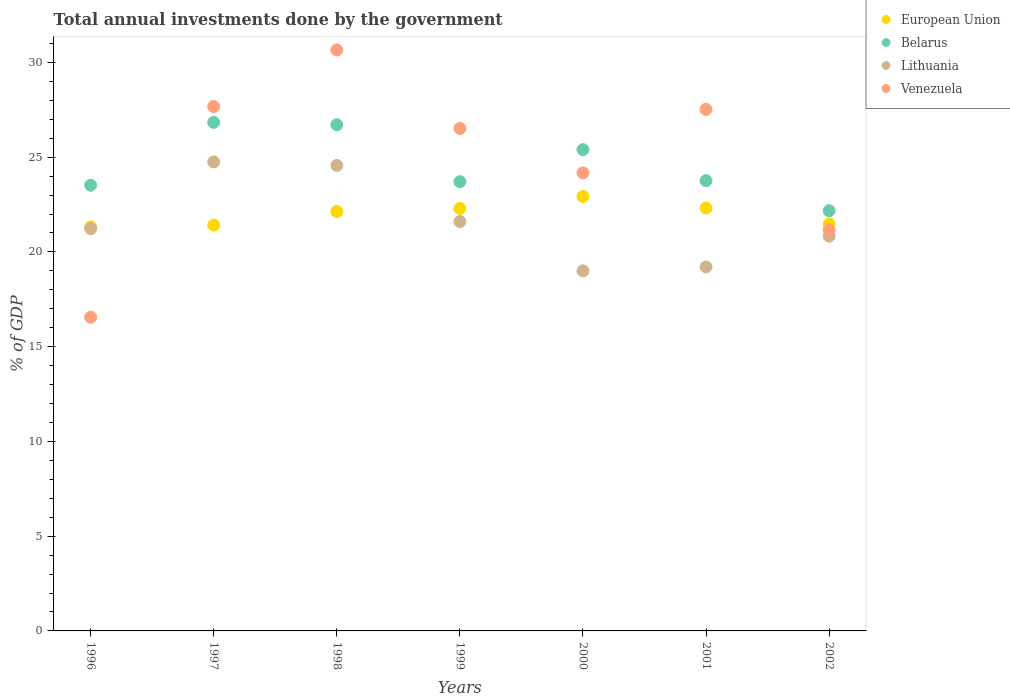How many different coloured dotlines are there?
Provide a succinct answer. 4. Is the number of dotlines equal to the number of legend labels?
Ensure brevity in your answer.  Yes. What is the total annual investments done by the government in European Union in 1999?
Your response must be concise. 22.3. Across all years, what is the maximum total annual investments done by the government in Lithuania?
Your answer should be compact. 24.75. Across all years, what is the minimum total annual investments done by the government in Venezuela?
Provide a succinct answer. 16.55. In which year was the total annual investments done by the government in European Union maximum?
Offer a very short reply. 2000. In which year was the total annual investments done by the government in Belarus minimum?
Keep it short and to the point. 2002. What is the total total annual investments done by the government in Venezuela in the graph?
Make the answer very short. 174.26. What is the difference between the total annual investments done by the government in Venezuela in 1998 and that in 2001?
Ensure brevity in your answer.  3.14. What is the difference between the total annual investments done by the government in Venezuela in 1998 and the total annual investments done by the government in European Union in 1997?
Ensure brevity in your answer.  9.25. What is the average total annual investments done by the government in European Union per year?
Keep it short and to the point. 21.98. In the year 1997, what is the difference between the total annual investments done by the government in Belarus and total annual investments done by the government in Venezuela?
Offer a very short reply. -0.84. In how many years, is the total annual investments done by the government in Venezuela greater than 9 %?
Keep it short and to the point. 7. What is the ratio of the total annual investments done by the government in European Union in 1997 to that in 1998?
Provide a succinct answer. 0.97. Is the difference between the total annual investments done by the government in Belarus in 1996 and 1997 greater than the difference between the total annual investments done by the government in Venezuela in 1996 and 1997?
Make the answer very short. Yes. What is the difference between the highest and the second highest total annual investments done by the government in European Union?
Offer a terse response. 0.61. What is the difference between the highest and the lowest total annual investments done by the government in Lithuania?
Provide a short and direct response. 5.75. Is the sum of the total annual investments done by the government in Venezuela in 2001 and 2002 greater than the maximum total annual investments done by the government in Lithuania across all years?
Make the answer very short. Yes. Is it the case that in every year, the sum of the total annual investments done by the government in Venezuela and total annual investments done by the government in Belarus  is greater than the sum of total annual investments done by the government in European Union and total annual investments done by the government in Lithuania?
Give a very brief answer. No. Is the total annual investments done by the government in Belarus strictly greater than the total annual investments done by the government in European Union over the years?
Provide a short and direct response. Yes. How many dotlines are there?
Provide a succinct answer. 4. How many years are there in the graph?
Keep it short and to the point. 7. What is the difference between two consecutive major ticks on the Y-axis?
Offer a terse response. 5. Are the values on the major ticks of Y-axis written in scientific E-notation?
Make the answer very short. No. How many legend labels are there?
Offer a terse response. 4. What is the title of the graph?
Give a very brief answer. Total annual investments done by the government. Does "Monaco" appear as one of the legend labels in the graph?
Offer a terse response. No. What is the label or title of the X-axis?
Your answer should be very brief. Years. What is the label or title of the Y-axis?
Ensure brevity in your answer.  % of GDP. What is the % of GDP in European Union in 1996?
Your response must be concise. 21.32. What is the % of GDP in Belarus in 1996?
Offer a terse response. 23.52. What is the % of GDP of Lithuania in 1996?
Ensure brevity in your answer.  21.23. What is the % of GDP in Venezuela in 1996?
Keep it short and to the point. 16.55. What is the % of GDP in European Union in 1997?
Provide a short and direct response. 21.41. What is the % of GDP in Belarus in 1997?
Give a very brief answer. 26.84. What is the % of GDP in Lithuania in 1997?
Offer a terse response. 24.75. What is the % of GDP in Venezuela in 1997?
Keep it short and to the point. 27.67. What is the % of GDP of European Union in 1998?
Offer a terse response. 22.13. What is the % of GDP of Belarus in 1998?
Your response must be concise. 26.71. What is the % of GDP in Lithuania in 1998?
Provide a succinct answer. 24.56. What is the % of GDP in Venezuela in 1998?
Provide a succinct answer. 30.66. What is the % of GDP of European Union in 1999?
Give a very brief answer. 22.3. What is the % of GDP in Belarus in 1999?
Make the answer very short. 23.71. What is the % of GDP in Lithuania in 1999?
Provide a succinct answer. 21.6. What is the % of GDP of Venezuela in 1999?
Offer a terse response. 26.52. What is the % of GDP of European Union in 2000?
Keep it short and to the point. 22.93. What is the % of GDP of Belarus in 2000?
Your answer should be very brief. 25.4. What is the % of GDP of Lithuania in 2000?
Keep it short and to the point. 19. What is the % of GDP of Venezuela in 2000?
Provide a succinct answer. 24.17. What is the % of GDP in European Union in 2001?
Keep it short and to the point. 22.31. What is the % of GDP in Belarus in 2001?
Offer a terse response. 23.76. What is the % of GDP in Lithuania in 2001?
Your answer should be compact. 19.21. What is the % of GDP of Venezuela in 2001?
Make the answer very short. 27.52. What is the % of GDP of European Union in 2002?
Provide a succinct answer. 21.48. What is the % of GDP in Belarus in 2002?
Your response must be concise. 22.18. What is the % of GDP of Lithuania in 2002?
Provide a succinct answer. 20.83. What is the % of GDP of Venezuela in 2002?
Ensure brevity in your answer.  21.16. Across all years, what is the maximum % of GDP in European Union?
Ensure brevity in your answer.  22.93. Across all years, what is the maximum % of GDP of Belarus?
Your answer should be very brief. 26.84. Across all years, what is the maximum % of GDP of Lithuania?
Provide a short and direct response. 24.75. Across all years, what is the maximum % of GDP in Venezuela?
Make the answer very short. 30.66. Across all years, what is the minimum % of GDP of European Union?
Your answer should be very brief. 21.32. Across all years, what is the minimum % of GDP of Belarus?
Give a very brief answer. 22.18. Across all years, what is the minimum % of GDP of Lithuania?
Provide a short and direct response. 19. Across all years, what is the minimum % of GDP in Venezuela?
Give a very brief answer. 16.55. What is the total % of GDP in European Union in the graph?
Make the answer very short. 153.88. What is the total % of GDP in Belarus in the graph?
Provide a short and direct response. 172.11. What is the total % of GDP of Lithuania in the graph?
Provide a short and direct response. 151.19. What is the total % of GDP of Venezuela in the graph?
Your answer should be very brief. 174.26. What is the difference between the % of GDP in European Union in 1996 and that in 1997?
Provide a short and direct response. -0.09. What is the difference between the % of GDP of Belarus in 1996 and that in 1997?
Ensure brevity in your answer.  -3.32. What is the difference between the % of GDP of Lithuania in 1996 and that in 1997?
Your response must be concise. -3.52. What is the difference between the % of GDP in Venezuela in 1996 and that in 1997?
Keep it short and to the point. -11.12. What is the difference between the % of GDP in European Union in 1996 and that in 1998?
Provide a short and direct response. -0.81. What is the difference between the % of GDP in Belarus in 1996 and that in 1998?
Ensure brevity in your answer.  -3.19. What is the difference between the % of GDP of Lithuania in 1996 and that in 1998?
Ensure brevity in your answer.  -3.33. What is the difference between the % of GDP in Venezuela in 1996 and that in 1998?
Your answer should be compact. -14.11. What is the difference between the % of GDP of European Union in 1996 and that in 1999?
Ensure brevity in your answer.  -0.97. What is the difference between the % of GDP in Belarus in 1996 and that in 1999?
Ensure brevity in your answer.  -0.19. What is the difference between the % of GDP of Lithuania in 1996 and that in 1999?
Offer a terse response. -0.38. What is the difference between the % of GDP of Venezuela in 1996 and that in 1999?
Keep it short and to the point. -9.96. What is the difference between the % of GDP of European Union in 1996 and that in 2000?
Provide a succinct answer. -1.6. What is the difference between the % of GDP in Belarus in 1996 and that in 2000?
Offer a very short reply. -1.88. What is the difference between the % of GDP of Lithuania in 1996 and that in 2000?
Provide a short and direct response. 2.23. What is the difference between the % of GDP of Venezuela in 1996 and that in 2000?
Ensure brevity in your answer.  -7.62. What is the difference between the % of GDP in European Union in 1996 and that in 2001?
Your answer should be very brief. -0.99. What is the difference between the % of GDP in Belarus in 1996 and that in 2001?
Your response must be concise. -0.24. What is the difference between the % of GDP in Lithuania in 1996 and that in 2001?
Ensure brevity in your answer.  2.02. What is the difference between the % of GDP of Venezuela in 1996 and that in 2001?
Ensure brevity in your answer.  -10.97. What is the difference between the % of GDP in European Union in 1996 and that in 2002?
Your response must be concise. -0.16. What is the difference between the % of GDP of Belarus in 1996 and that in 2002?
Give a very brief answer. 1.34. What is the difference between the % of GDP of Lithuania in 1996 and that in 2002?
Offer a very short reply. 0.4. What is the difference between the % of GDP of Venezuela in 1996 and that in 2002?
Make the answer very short. -4.6. What is the difference between the % of GDP of European Union in 1997 and that in 1998?
Ensure brevity in your answer.  -0.72. What is the difference between the % of GDP in Belarus in 1997 and that in 1998?
Make the answer very short. 0.12. What is the difference between the % of GDP in Lithuania in 1997 and that in 1998?
Give a very brief answer. 0.19. What is the difference between the % of GDP of Venezuela in 1997 and that in 1998?
Your answer should be compact. -2.99. What is the difference between the % of GDP in European Union in 1997 and that in 1999?
Your answer should be very brief. -0.88. What is the difference between the % of GDP in Belarus in 1997 and that in 1999?
Your answer should be very brief. 3.13. What is the difference between the % of GDP in Lithuania in 1997 and that in 1999?
Your response must be concise. 3.15. What is the difference between the % of GDP of Venezuela in 1997 and that in 1999?
Your answer should be compact. 1.16. What is the difference between the % of GDP in European Union in 1997 and that in 2000?
Your answer should be compact. -1.51. What is the difference between the % of GDP of Belarus in 1997 and that in 2000?
Offer a terse response. 1.44. What is the difference between the % of GDP in Lithuania in 1997 and that in 2000?
Offer a very short reply. 5.75. What is the difference between the % of GDP in Venezuela in 1997 and that in 2000?
Offer a very short reply. 3.5. What is the difference between the % of GDP in European Union in 1997 and that in 2001?
Your answer should be compact. -0.9. What is the difference between the % of GDP of Belarus in 1997 and that in 2001?
Offer a very short reply. 3.08. What is the difference between the % of GDP of Lithuania in 1997 and that in 2001?
Your answer should be compact. 5.54. What is the difference between the % of GDP of Venezuela in 1997 and that in 2001?
Your answer should be compact. 0.15. What is the difference between the % of GDP in European Union in 1997 and that in 2002?
Provide a short and direct response. -0.06. What is the difference between the % of GDP of Belarus in 1997 and that in 2002?
Your response must be concise. 4.66. What is the difference between the % of GDP in Lithuania in 1997 and that in 2002?
Offer a very short reply. 3.92. What is the difference between the % of GDP of Venezuela in 1997 and that in 2002?
Make the answer very short. 6.51. What is the difference between the % of GDP in European Union in 1998 and that in 1999?
Keep it short and to the point. -0.16. What is the difference between the % of GDP in Belarus in 1998 and that in 1999?
Provide a short and direct response. 3.01. What is the difference between the % of GDP in Lithuania in 1998 and that in 1999?
Offer a terse response. 2.96. What is the difference between the % of GDP in Venezuela in 1998 and that in 1999?
Offer a very short reply. 4.14. What is the difference between the % of GDP in European Union in 1998 and that in 2000?
Your answer should be compact. -0.79. What is the difference between the % of GDP of Belarus in 1998 and that in 2000?
Your answer should be very brief. 1.31. What is the difference between the % of GDP of Lithuania in 1998 and that in 2000?
Your response must be concise. 5.56. What is the difference between the % of GDP of Venezuela in 1998 and that in 2000?
Make the answer very short. 6.49. What is the difference between the % of GDP in European Union in 1998 and that in 2001?
Give a very brief answer. -0.18. What is the difference between the % of GDP in Belarus in 1998 and that in 2001?
Offer a terse response. 2.95. What is the difference between the % of GDP of Lithuania in 1998 and that in 2001?
Your response must be concise. 5.36. What is the difference between the % of GDP in Venezuela in 1998 and that in 2001?
Offer a terse response. 3.14. What is the difference between the % of GDP in European Union in 1998 and that in 2002?
Ensure brevity in your answer.  0.66. What is the difference between the % of GDP of Belarus in 1998 and that in 2002?
Offer a terse response. 4.54. What is the difference between the % of GDP in Lithuania in 1998 and that in 2002?
Offer a very short reply. 3.73. What is the difference between the % of GDP of Venezuela in 1998 and that in 2002?
Give a very brief answer. 9.5. What is the difference between the % of GDP in European Union in 1999 and that in 2000?
Keep it short and to the point. -0.63. What is the difference between the % of GDP in Belarus in 1999 and that in 2000?
Keep it short and to the point. -1.69. What is the difference between the % of GDP in Lithuania in 1999 and that in 2000?
Your answer should be compact. 2.6. What is the difference between the % of GDP of Venezuela in 1999 and that in 2000?
Ensure brevity in your answer.  2.35. What is the difference between the % of GDP in European Union in 1999 and that in 2001?
Your response must be concise. -0.02. What is the difference between the % of GDP of Belarus in 1999 and that in 2001?
Offer a very short reply. -0.05. What is the difference between the % of GDP in Lithuania in 1999 and that in 2001?
Give a very brief answer. 2.4. What is the difference between the % of GDP of Venezuela in 1999 and that in 2001?
Offer a very short reply. -1.01. What is the difference between the % of GDP of European Union in 1999 and that in 2002?
Keep it short and to the point. 0.82. What is the difference between the % of GDP of Belarus in 1999 and that in 2002?
Ensure brevity in your answer.  1.53. What is the difference between the % of GDP of Lithuania in 1999 and that in 2002?
Your answer should be compact. 0.77. What is the difference between the % of GDP in Venezuela in 1999 and that in 2002?
Your answer should be very brief. 5.36. What is the difference between the % of GDP in European Union in 2000 and that in 2001?
Ensure brevity in your answer.  0.61. What is the difference between the % of GDP of Belarus in 2000 and that in 2001?
Provide a short and direct response. 1.64. What is the difference between the % of GDP of Lithuania in 2000 and that in 2001?
Your answer should be very brief. -0.21. What is the difference between the % of GDP in Venezuela in 2000 and that in 2001?
Give a very brief answer. -3.35. What is the difference between the % of GDP in European Union in 2000 and that in 2002?
Make the answer very short. 1.45. What is the difference between the % of GDP in Belarus in 2000 and that in 2002?
Give a very brief answer. 3.22. What is the difference between the % of GDP in Lithuania in 2000 and that in 2002?
Your response must be concise. -1.83. What is the difference between the % of GDP of Venezuela in 2000 and that in 2002?
Your answer should be very brief. 3.01. What is the difference between the % of GDP in European Union in 2001 and that in 2002?
Offer a terse response. 0.84. What is the difference between the % of GDP of Belarus in 2001 and that in 2002?
Your answer should be compact. 1.58. What is the difference between the % of GDP in Lithuania in 2001 and that in 2002?
Your response must be concise. -1.63. What is the difference between the % of GDP of Venezuela in 2001 and that in 2002?
Offer a very short reply. 6.37. What is the difference between the % of GDP of European Union in 1996 and the % of GDP of Belarus in 1997?
Offer a very short reply. -5.52. What is the difference between the % of GDP in European Union in 1996 and the % of GDP in Lithuania in 1997?
Make the answer very short. -3.43. What is the difference between the % of GDP of European Union in 1996 and the % of GDP of Venezuela in 1997?
Ensure brevity in your answer.  -6.35. What is the difference between the % of GDP in Belarus in 1996 and the % of GDP in Lithuania in 1997?
Offer a terse response. -1.23. What is the difference between the % of GDP of Belarus in 1996 and the % of GDP of Venezuela in 1997?
Offer a very short reply. -4.15. What is the difference between the % of GDP in Lithuania in 1996 and the % of GDP in Venezuela in 1997?
Keep it short and to the point. -6.44. What is the difference between the % of GDP of European Union in 1996 and the % of GDP of Belarus in 1998?
Make the answer very short. -5.39. What is the difference between the % of GDP in European Union in 1996 and the % of GDP in Lithuania in 1998?
Provide a succinct answer. -3.24. What is the difference between the % of GDP in European Union in 1996 and the % of GDP in Venezuela in 1998?
Your answer should be very brief. -9.34. What is the difference between the % of GDP in Belarus in 1996 and the % of GDP in Lithuania in 1998?
Give a very brief answer. -1.05. What is the difference between the % of GDP of Belarus in 1996 and the % of GDP of Venezuela in 1998?
Provide a short and direct response. -7.14. What is the difference between the % of GDP in Lithuania in 1996 and the % of GDP in Venezuela in 1998?
Your answer should be very brief. -9.43. What is the difference between the % of GDP of European Union in 1996 and the % of GDP of Belarus in 1999?
Your response must be concise. -2.39. What is the difference between the % of GDP in European Union in 1996 and the % of GDP in Lithuania in 1999?
Your response must be concise. -0.28. What is the difference between the % of GDP in European Union in 1996 and the % of GDP in Venezuela in 1999?
Keep it short and to the point. -5.2. What is the difference between the % of GDP in Belarus in 1996 and the % of GDP in Lithuania in 1999?
Offer a terse response. 1.91. What is the difference between the % of GDP in Belarus in 1996 and the % of GDP in Venezuela in 1999?
Provide a succinct answer. -3. What is the difference between the % of GDP in Lithuania in 1996 and the % of GDP in Venezuela in 1999?
Make the answer very short. -5.29. What is the difference between the % of GDP in European Union in 1996 and the % of GDP in Belarus in 2000?
Give a very brief answer. -4.08. What is the difference between the % of GDP of European Union in 1996 and the % of GDP of Lithuania in 2000?
Ensure brevity in your answer.  2.32. What is the difference between the % of GDP in European Union in 1996 and the % of GDP in Venezuela in 2000?
Make the answer very short. -2.85. What is the difference between the % of GDP of Belarus in 1996 and the % of GDP of Lithuania in 2000?
Your answer should be very brief. 4.52. What is the difference between the % of GDP of Belarus in 1996 and the % of GDP of Venezuela in 2000?
Make the answer very short. -0.65. What is the difference between the % of GDP of Lithuania in 1996 and the % of GDP of Venezuela in 2000?
Ensure brevity in your answer.  -2.94. What is the difference between the % of GDP in European Union in 1996 and the % of GDP in Belarus in 2001?
Offer a very short reply. -2.44. What is the difference between the % of GDP of European Union in 1996 and the % of GDP of Lithuania in 2001?
Provide a short and direct response. 2.11. What is the difference between the % of GDP in European Union in 1996 and the % of GDP in Venezuela in 2001?
Make the answer very short. -6.2. What is the difference between the % of GDP in Belarus in 1996 and the % of GDP in Lithuania in 2001?
Offer a terse response. 4.31. What is the difference between the % of GDP in Belarus in 1996 and the % of GDP in Venezuela in 2001?
Keep it short and to the point. -4.01. What is the difference between the % of GDP in Lithuania in 1996 and the % of GDP in Venezuela in 2001?
Your response must be concise. -6.29. What is the difference between the % of GDP in European Union in 1996 and the % of GDP in Belarus in 2002?
Offer a terse response. -0.86. What is the difference between the % of GDP of European Union in 1996 and the % of GDP of Lithuania in 2002?
Your answer should be compact. 0.49. What is the difference between the % of GDP in European Union in 1996 and the % of GDP in Venezuela in 2002?
Offer a terse response. 0.16. What is the difference between the % of GDP of Belarus in 1996 and the % of GDP of Lithuania in 2002?
Provide a succinct answer. 2.69. What is the difference between the % of GDP of Belarus in 1996 and the % of GDP of Venezuela in 2002?
Offer a very short reply. 2.36. What is the difference between the % of GDP in Lithuania in 1996 and the % of GDP in Venezuela in 2002?
Keep it short and to the point. 0.07. What is the difference between the % of GDP of European Union in 1997 and the % of GDP of Belarus in 1998?
Ensure brevity in your answer.  -5.3. What is the difference between the % of GDP in European Union in 1997 and the % of GDP in Lithuania in 1998?
Offer a terse response. -3.15. What is the difference between the % of GDP in European Union in 1997 and the % of GDP in Venezuela in 1998?
Make the answer very short. -9.25. What is the difference between the % of GDP in Belarus in 1997 and the % of GDP in Lithuania in 1998?
Your response must be concise. 2.27. What is the difference between the % of GDP of Belarus in 1997 and the % of GDP of Venezuela in 1998?
Offer a very short reply. -3.82. What is the difference between the % of GDP of Lithuania in 1997 and the % of GDP of Venezuela in 1998?
Your response must be concise. -5.91. What is the difference between the % of GDP in European Union in 1997 and the % of GDP in Belarus in 1999?
Offer a terse response. -2.29. What is the difference between the % of GDP of European Union in 1997 and the % of GDP of Lithuania in 1999?
Give a very brief answer. -0.19. What is the difference between the % of GDP of European Union in 1997 and the % of GDP of Venezuela in 1999?
Make the answer very short. -5.1. What is the difference between the % of GDP of Belarus in 1997 and the % of GDP of Lithuania in 1999?
Provide a succinct answer. 5.23. What is the difference between the % of GDP in Belarus in 1997 and the % of GDP in Venezuela in 1999?
Your answer should be very brief. 0.32. What is the difference between the % of GDP in Lithuania in 1997 and the % of GDP in Venezuela in 1999?
Offer a very short reply. -1.76. What is the difference between the % of GDP of European Union in 1997 and the % of GDP of Belarus in 2000?
Offer a very short reply. -3.98. What is the difference between the % of GDP of European Union in 1997 and the % of GDP of Lithuania in 2000?
Your answer should be very brief. 2.41. What is the difference between the % of GDP in European Union in 1997 and the % of GDP in Venezuela in 2000?
Offer a terse response. -2.76. What is the difference between the % of GDP in Belarus in 1997 and the % of GDP in Lithuania in 2000?
Your response must be concise. 7.83. What is the difference between the % of GDP of Belarus in 1997 and the % of GDP of Venezuela in 2000?
Provide a short and direct response. 2.67. What is the difference between the % of GDP in Lithuania in 1997 and the % of GDP in Venezuela in 2000?
Your answer should be compact. 0.58. What is the difference between the % of GDP in European Union in 1997 and the % of GDP in Belarus in 2001?
Your response must be concise. -2.35. What is the difference between the % of GDP of European Union in 1997 and the % of GDP of Lithuania in 2001?
Keep it short and to the point. 2.21. What is the difference between the % of GDP of European Union in 1997 and the % of GDP of Venezuela in 2001?
Provide a succinct answer. -6.11. What is the difference between the % of GDP in Belarus in 1997 and the % of GDP in Lithuania in 2001?
Offer a terse response. 7.63. What is the difference between the % of GDP of Belarus in 1997 and the % of GDP of Venezuela in 2001?
Offer a terse response. -0.69. What is the difference between the % of GDP of Lithuania in 1997 and the % of GDP of Venezuela in 2001?
Your answer should be very brief. -2.77. What is the difference between the % of GDP in European Union in 1997 and the % of GDP in Belarus in 2002?
Provide a succinct answer. -0.76. What is the difference between the % of GDP in European Union in 1997 and the % of GDP in Lithuania in 2002?
Your answer should be very brief. 0.58. What is the difference between the % of GDP in European Union in 1997 and the % of GDP in Venezuela in 2002?
Offer a terse response. 0.26. What is the difference between the % of GDP in Belarus in 1997 and the % of GDP in Lithuania in 2002?
Keep it short and to the point. 6. What is the difference between the % of GDP in Belarus in 1997 and the % of GDP in Venezuela in 2002?
Your answer should be compact. 5.68. What is the difference between the % of GDP in Lithuania in 1997 and the % of GDP in Venezuela in 2002?
Make the answer very short. 3.59. What is the difference between the % of GDP in European Union in 1998 and the % of GDP in Belarus in 1999?
Make the answer very short. -1.57. What is the difference between the % of GDP in European Union in 1998 and the % of GDP in Lithuania in 1999?
Your response must be concise. 0.53. What is the difference between the % of GDP in European Union in 1998 and the % of GDP in Venezuela in 1999?
Your answer should be compact. -4.38. What is the difference between the % of GDP of Belarus in 1998 and the % of GDP of Lithuania in 1999?
Make the answer very short. 5.11. What is the difference between the % of GDP in Belarus in 1998 and the % of GDP in Venezuela in 1999?
Your response must be concise. 0.2. What is the difference between the % of GDP of Lithuania in 1998 and the % of GDP of Venezuela in 1999?
Give a very brief answer. -1.95. What is the difference between the % of GDP in European Union in 1998 and the % of GDP in Belarus in 2000?
Your answer should be compact. -3.26. What is the difference between the % of GDP of European Union in 1998 and the % of GDP of Lithuania in 2000?
Provide a short and direct response. 3.13. What is the difference between the % of GDP in European Union in 1998 and the % of GDP in Venezuela in 2000?
Ensure brevity in your answer.  -2.04. What is the difference between the % of GDP of Belarus in 1998 and the % of GDP of Lithuania in 2000?
Your response must be concise. 7.71. What is the difference between the % of GDP in Belarus in 1998 and the % of GDP in Venezuela in 2000?
Offer a very short reply. 2.54. What is the difference between the % of GDP in Lithuania in 1998 and the % of GDP in Venezuela in 2000?
Keep it short and to the point. 0.39. What is the difference between the % of GDP in European Union in 1998 and the % of GDP in Belarus in 2001?
Your answer should be compact. -1.63. What is the difference between the % of GDP of European Union in 1998 and the % of GDP of Lithuania in 2001?
Ensure brevity in your answer.  2.93. What is the difference between the % of GDP in European Union in 1998 and the % of GDP in Venezuela in 2001?
Give a very brief answer. -5.39. What is the difference between the % of GDP of Belarus in 1998 and the % of GDP of Lithuania in 2001?
Give a very brief answer. 7.5. What is the difference between the % of GDP in Belarus in 1998 and the % of GDP in Venezuela in 2001?
Keep it short and to the point. -0.81. What is the difference between the % of GDP in Lithuania in 1998 and the % of GDP in Venezuela in 2001?
Ensure brevity in your answer.  -2.96. What is the difference between the % of GDP in European Union in 1998 and the % of GDP in Belarus in 2002?
Make the answer very short. -0.04. What is the difference between the % of GDP in European Union in 1998 and the % of GDP in Lithuania in 2002?
Offer a very short reply. 1.3. What is the difference between the % of GDP of European Union in 1998 and the % of GDP of Venezuela in 2002?
Your response must be concise. 0.98. What is the difference between the % of GDP of Belarus in 1998 and the % of GDP of Lithuania in 2002?
Your response must be concise. 5.88. What is the difference between the % of GDP of Belarus in 1998 and the % of GDP of Venezuela in 2002?
Keep it short and to the point. 5.55. What is the difference between the % of GDP in Lithuania in 1998 and the % of GDP in Venezuela in 2002?
Offer a terse response. 3.41. What is the difference between the % of GDP of European Union in 1999 and the % of GDP of Belarus in 2000?
Keep it short and to the point. -3.1. What is the difference between the % of GDP of European Union in 1999 and the % of GDP of Lithuania in 2000?
Your response must be concise. 3.29. What is the difference between the % of GDP in European Union in 1999 and the % of GDP in Venezuela in 2000?
Provide a short and direct response. -1.88. What is the difference between the % of GDP of Belarus in 1999 and the % of GDP of Lithuania in 2000?
Give a very brief answer. 4.7. What is the difference between the % of GDP of Belarus in 1999 and the % of GDP of Venezuela in 2000?
Provide a succinct answer. -0.46. What is the difference between the % of GDP in Lithuania in 1999 and the % of GDP in Venezuela in 2000?
Offer a very short reply. -2.57. What is the difference between the % of GDP of European Union in 1999 and the % of GDP of Belarus in 2001?
Make the answer very short. -1.47. What is the difference between the % of GDP of European Union in 1999 and the % of GDP of Lithuania in 2001?
Your answer should be very brief. 3.09. What is the difference between the % of GDP of European Union in 1999 and the % of GDP of Venezuela in 2001?
Your answer should be compact. -5.23. What is the difference between the % of GDP in Belarus in 1999 and the % of GDP in Lithuania in 2001?
Your answer should be compact. 4.5. What is the difference between the % of GDP of Belarus in 1999 and the % of GDP of Venezuela in 2001?
Give a very brief answer. -3.82. What is the difference between the % of GDP of Lithuania in 1999 and the % of GDP of Venezuela in 2001?
Ensure brevity in your answer.  -5.92. What is the difference between the % of GDP of European Union in 1999 and the % of GDP of Belarus in 2002?
Give a very brief answer. 0.12. What is the difference between the % of GDP of European Union in 1999 and the % of GDP of Lithuania in 2002?
Provide a succinct answer. 1.46. What is the difference between the % of GDP of European Union in 1999 and the % of GDP of Venezuela in 2002?
Your answer should be very brief. 1.14. What is the difference between the % of GDP in Belarus in 1999 and the % of GDP in Lithuania in 2002?
Make the answer very short. 2.87. What is the difference between the % of GDP in Belarus in 1999 and the % of GDP in Venezuela in 2002?
Make the answer very short. 2.55. What is the difference between the % of GDP of Lithuania in 1999 and the % of GDP of Venezuela in 2002?
Keep it short and to the point. 0.45. What is the difference between the % of GDP of European Union in 2000 and the % of GDP of Belarus in 2001?
Ensure brevity in your answer.  -0.83. What is the difference between the % of GDP in European Union in 2000 and the % of GDP in Lithuania in 2001?
Provide a short and direct response. 3.72. What is the difference between the % of GDP in European Union in 2000 and the % of GDP in Venezuela in 2001?
Keep it short and to the point. -4.6. What is the difference between the % of GDP in Belarus in 2000 and the % of GDP in Lithuania in 2001?
Provide a succinct answer. 6.19. What is the difference between the % of GDP in Belarus in 2000 and the % of GDP in Venezuela in 2001?
Provide a succinct answer. -2.13. What is the difference between the % of GDP in Lithuania in 2000 and the % of GDP in Venezuela in 2001?
Provide a short and direct response. -8.52. What is the difference between the % of GDP in European Union in 2000 and the % of GDP in Belarus in 2002?
Ensure brevity in your answer.  0.75. What is the difference between the % of GDP in European Union in 2000 and the % of GDP in Lithuania in 2002?
Your response must be concise. 2.09. What is the difference between the % of GDP in European Union in 2000 and the % of GDP in Venezuela in 2002?
Keep it short and to the point. 1.77. What is the difference between the % of GDP in Belarus in 2000 and the % of GDP in Lithuania in 2002?
Provide a succinct answer. 4.57. What is the difference between the % of GDP in Belarus in 2000 and the % of GDP in Venezuela in 2002?
Offer a terse response. 4.24. What is the difference between the % of GDP in Lithuania in 2000 and the % of GDP in Venezuela in 2002?
Provide a succinct answer. -2.16. What is the difference between the % of GDP of European Union in 2001 and the % of GDP of Belarus in 2002?
Offer a terse response. 0.14. What is the difference between the % of GDP of European Union in 2001 and the % of GDP of Lithuania in 2002?
Your answer should be very brief. 1.48. What is the difference between the % of GDP in European Union in 2001 and the % of GDP in Venezuela in 2002?
Keep it short and to the point. 1.16. What is the difference between the % of GDP in Belarus in 2001 and the % of GDP in Lithuania in 2002?
Your answer should be compact. 2.93. What is the difference between the % of GDP of Belarus in 2001 and the % of GDP of Venezuela in 2002?
Offer a very short reply. 2.6. What is the difference between the % of GDP of Lithuania in 2001 and the % of GDP of Venezuela in 2002?
Provide a short and direct response. -1.95. What is the average % of GDP of European Union per year?
Your answer should be compact. 21.98. What is the average % of GDP of Belarus per year?
Offer a very short reply. 24.59. What is the average % of GDP in Lithuania per year?
Offer a terse response. 21.6. What is the average % of GDP in Venezuela per year?
Your answer should be very brief. 24.89. In the year 1996, what is the difference between the % of GDP of European Union and % of GDP of Belarus?
Keep it short and to the point. -2.2. In the year 1996, what is the difference between the % of GDP in European Union and % of GDP in Lithuania?
Make the answer very short. 0.09. In the year 1996, what is the difference between the % of GDP of European Union and % of GDP of Venezuela?
Give a very brief answer. 4.77. In the year 1996, what is the difference between the % of GDP in Belarus and % of GDP in Lithuania?
Keep it short and to the point. 2.29. In the year 1996, what is the difference between the % of GDP in Belarus and % of GDP in Venezuela?
Offer a terse response. 6.96. In the year 1996, what is the difference between the % of GDP in Lithuania and % of GDP in Venezuela?
Make the answer very short. 4.67. In the year 1997, what is the difference between the % of GDP in European Union and % of GDP in Belarus?
Your response must be concise. -5.42. In the year 1997, what is the difference between the % of GDP of European Union and % of GDP of Lithuania?
Keep it short and to the point. -3.34. In the year 1997, what is the difference between the % of GDP in European Union and % of GDP in Venezuela?
Keep it short and to the point. -6.26. In the year 1997, what is the difference between the % of GDP in Belarus and % of GDP in Lithuania?
Ensure brevity in your answer.  2.08. In the year 1997, what is the difference between the % of GDP of Belarus and % of GDP of Venezuela?
Keep it short and to the point. -0.84. In the year 1997, what is the difference between the % of GDP in Lithuania and % of GDP in Venezuela?
Your answer should be compact. -2.92. In the year 1998, what is the difference between the % of GDP in European Union and % of GDP in Belarus?
Provide a succinct answer. -4.58. In the year 1998, what is the difference between the % of GDP in European Union and % of GDP in Lithuania?
Your answer should be compact. -2.43. In the year 1998, what is the difference between the % of GDP of European Union and % of GDP of Venezuela?
Ensure brevity in your answer.  -8.53. In the year 1998, what is the difference between the % of GDP in Belarus and % of GDP in Lithuania?
Your answer should be compact. 2.15. In the year 1998, what is the difference between the % of GDP of Belarus and % of GDP of Venezuela?
Provide a succinct answer. -3.95. In the year 1998, what is the difference between the % of GDP in Lithuania and % of GDP in Venezuela?
Offer a terse response. -6.1. In the year 1999, what is the difference between the % of GDP in European Union and % of GDP in Belarus?
Keep it short and to the point. -1.41. In the year 1999, what is the difference between the % of GDP in European Union and % of GDP in Lithuania?
Give a very brief answer. 0.69. In the year 1999, what is the difference between the % of GDP in European Union and % of GDP in Venezuela?
Keep it short and to the point. -4.22. In the year 1999, what is the difference between the % of GDP of Belarus and % of GDP of Lithuania?
Your answer should be compact. 2.1. In the year 1999, what is the difference between the % of GDP of Belarus and % of GDP of Venezuela?
Provide a short and direct response. -2.81. In the year 1999, what is the difference between the % of GDP of Lithuania and % of GDP of Venezuela?
Make the answer very short. -4.91. In the year 2000, what is the difference between the % of GDP in European Union and % of GDP in Belarus?
Ensure brevity in your answer.  -2.47. In the year 2000, what is the difference between the % of GDP of European Union and % of GDP of Lithuania?
Ensure brevity in your answer.  3.92. In the year 2000, what is the difference between the % of GDP in European Union and % of GDP in Venezuela?
Keep it short and to the point. -1.24. In the year 2000, what is the difference between the % of GDP of Belarus and % of GDP of Lithuania?
Make the answer very short. 6.4. In the year 2000, what is the difference between the % of GDP of Belarus and % of GDP of Venezuela?
Keep it short and to the point. 1.23. In the year 2000, what is the difference between the % of GDP in Lithuania and % of GDP in Venezuela?
Offer a terse response. -5.17. In the year 2001, what is the difference between the % of GDP in European Union and % of GDP in Belarus?
Your response must be concise. -1.45. In the year 2001, what is the difference between the % of GDP in European Union and % of GDP in Lithuania?
Make the answer very short. 3.11. In the year 2001, what is the difference between the % of GDP of European Union and % of GDP of Venezuela?
Keep it short and to the point. -5.21. In the year 2001, what is the difference between the % of GDP of Belarus and % of GDP of Lithuania?
Your answer should be compact. 4.55. In the year 2001, what is the difference between the % of GDP in Belarus and % of GDP in Venezuela?
Offer a very short reply. -3.76. In the year 2001, what is the difference between the % of GDP of Lithuania and % of GDP of Venezuela?
Your answer should be compact. -8.32. In the year 2002, what is the difference between the % of GDP in European Union and % of GDP in Belarus?
Make the answer very short. -0.7. In the year 2002, what is the difference between the % of GDP in European Union and % of GDP in Lithuania?
Make the answer very short. 0.64. In the year 2002, what is the difference between the % of GDP of European Union and % of GDP of Venezuela?
Ensure brevity in your answer.  0.32. In the year 2002, what is the difference between the % of GDP of Belarus and % of GDP of Lithuania?
Offer a terse response. 1.34. In the year 2002, what is the difference between the % of GDP of Belarus and % of GDP of Venezuela?
Ensure brevity in your answer.  1.02. In the year 2002, what is the difference between the % of GDP in Lithuania and % of GDP in Venezuela?
Keep it short and to the point. -0.33. What is the ratio of the % of GDP in European Union in 1996 to that in 1997?
Make the answer very short. 1. What is the ratio of the % of GDP in Belarus in 1996 to that in 1997?
Your answer should be very brief. 0.88. What is the ratio of the % of GDP of Lithuania in 1996 to that in 1997?
Offer a terse response. 0.86. What is the ratio of the % of GDP in Venezuela in 1996 to that in 1997?
Offer a terse response. 0.6. What is the ratio of the % of GDP in European Union in 1996 to that in 1998?
Make the answer very short. 0.96. What is the ratio of the % of GDP in Belarus in 1996 to that in 1998?
Your answer should be compact. 0.88. What is the ratio of the % of GDP in Lithuania in 1996 to that in 1998?
Your response must be concise. 0.86. What is the ratio of the % of GDP in Venezuela in 1996 to that in 1998?
Provide a succinct answer. 0.54. What is the ratio of the % of GDP of European Union in 1996 to that in 1999?
Provide a short and direct response. 0.96. What is the ratio of the % of GDP in Lithuania in 1996 to that in 1999?
Your answer should be compact. 0.98. What is the ratio of the % of GDP in Venezuela in 1996 to that in 1999?
Offer a terse response. 0.62. What is the ratio of the % of GDP of Belarus in 1996 to that in 2000?
Make the answer very short. 0.93. What is the ratio of the % of GDP of Lithuania in 1996 to that in 2000?
Your answer should be very brief. 1.12. What is the ratio of the % of GDP of Venezuela in 1996 to that in 2000?
Ensure brevity in your answer.  0.68. What is the ratio of the % of GDP of European Union in 1996 to that in 2001?
Keep it short and to the point. 0.96. What is the ratio of the % of GDP of Belarus in 1996 to that in 2001?
Offer a very short reply. 0.99. What is the ratio of the % of GDP of Lithuania in 1996 to that in 2001?
Keep it short and to the point. 1.11. What is the ratio of the % of GDP of Venezuela in 1996 to that in 2001?
Provide a succinct answer. 0.6. What is the ratio of the % of GDP of Belarus in 1996 to that in 2002?
Keep it short and to the point. 1.06. What is the ratio of the % of GDP in Lithuania in 1996 to that in 2002?
Your answer should be very brief. 1.02. What is the ratio of the % of GDP in Venezuela in 1996 to that in 2002?
Your answer should be very brief. 0.78. What is the ratio of the % of GDP of European Union in 1997 to that in 1998?
Your answer should be very brief. 0.97. What is the ratio of the % of GDP in Lithuania in 1997 to that in 1998?
Offer a terse response. 1.01. What is the ratio of the % of GDP of Venezuela in 1997 to that in 1998?
Ensure brevity in your answer.  0.9. What is the ratio of the % of GDP in European Union in 1997 to that in 1999?
Make the answer very short. 0.96. What is the ratio of the % of GDP of Belarus in 1997 to that in 1999?
Your response must be concise. 1.13. What is the ratio of the % of GDP of Lithuania in 1997 to that in 1999?
Make the answer very short. 1.15. What is the ratio of the % of GDP of Venezuela in 1997 to that in 1999?
Your response must be concise. 1.04. What is the ratio of the % of GDP in European Union in 1997 to that in 2000?
Make the answer very short. 0.93. What is the ratio of the % of GDP of Belarus in 1997 to that in 2000?
Keep it short and to the point. 1.06. What is the ratio of the % of GDP in Lithuania in 1997 to that in 2000?
Give a very brief answer. 1.3. What is the ratio of the % of GDP of Venezuela in 1997 to that in 2000?
Provide a succinct answer. 1.14. What is the ratio of the % of GDP of European Union in 1997 to that in 2001?
Offer a terse response. 0.96. What is the ratio of the % of GDP of Belarus in 1997 to that in 2001?
Your answer should be compact. 1.13. What is the ratio of the % of GDP in Lithuania in 1997 to that in 2001?
Provide a succinct answer. 1.29. What is the ratio of the % of GDP of Venezuela in 1997 to that in 2001?
Provide a succinct answer. 1.01. What is the ratio of the % of GDP of Belarus in 1997 to that in 2002?
Give a very brief answer. 1.21. What is the ratio of the % of GDP in Lithuania in 1997 to that in 2002?
Your response must be concise. 1.19. What is the ratio of the % of GDP of Venezuela in 1997 to that in 2002?
Give a very brief answer. 1.31. What is the ratio of the % of GDP of Belarus in 1998 to that in 1999?
Keep it short and to the point. 1.13. What is the ratio of the % of GDP of Lithuania in 1998 to that in 1999?
Offer a very short reply. 1.14. What is the ratio of the % of GDP of Venezuela in 1998 to that in 1999?
Provide a succinct answer. 1.16. What is the ratio of the % of GDP of European Union in 1998 to that in 2000?
Make the answer very short. 0.97. What is the ratio of the % of GDP of Belarus in 1998 to that in 2000?
Keep it short and to the point. 1.05. What is the ratio of the % of GDP in Lithuania in 1998 to that in 2000?
Provide a short and direct response. 1.29. What is the ratio of the % of GDP of Venezuela in 1998 to that in 2000?
Provide a short and direct response. 1.27. What is the ratio of the % of GDP of Belarus in 1998 to that in 2001?
Your answer should be very brief. 1.12. What is the ratio of the % of GDP in Lithuania in 1998 to that in 2001?
Offer a terse response. 1.28. What is the ratio of the % of GDP in Venezuela in 1998 to that in 2001?
Your answer should be very brief. 1.11. What is the ratio of the % of GDP of European Union in 1998 to that in 2002?
Give a very brief answer. 1.03. What is the ratio of the % of GDP in Belarus in 1998 to that in 2002?
Your answer should be compact. 1.2. What is the ratio of the % of GDP in Lithuania in 1998 to that in 2002?
Provide a succinct answer. 1.18. What is the ratio of the % of GDP of Venezuela in 1998 to that in 2002?
Your answer should be compact. 1.45. What is the ratio of the % of GDP of European Union in 1999 to that in 2000?
Provide a short and direct response. 0.97. What is the ratio of the % of GDP of Belarus in 1999 to that in 2000?
Your response must be concise. 0.93. What is the ratio of the % of GDP in Lithuania in 1999 to that in 2000?
Offer a terse response. 1.14. What is the ratio of the % of GDP of Venezuela in 1999 to that in 2000?
Provide a short and direct response. 1.1. What is the ratio of the % of GDP of Lithuania in 1999 to that in 2001?
Your response must be concise. 1.12. What is the ratio of the % of GDP of Venezuela in 1999 to that in 2001?
Provide a short and direct response. 0.96. What is the ratio of the % of GDP in European Union in 1999 to that in 2002?
Give a very brief answer. 1.04. What is the ratio of the % of GDP in Belarus in 1999 to that in 2002?
Offer a very short reply. 1.07. What is the ratio of the % of GDP of Venezuela in 1999 to that in 2002?
Provide a short and direct response. 1.25. What is the ratio of the % of GDP in European Union in 2000 to that in 2001?
Your response must be concise. 1.03. What is the ratio of the % of GDP in Belarus in 2000 to that in 2001?
Keep it short and to the point. 1.07. What is the ratio of the % of GDP of Lithuania in 2000 to that in 2001?
Offer a very short reply. 0.99. What is the ratio of the % of GDP of Venezuela in 2000 to that in 2001?
Provide a short and direct response. 0.88. What is the ratio of the % of GDP of European Union in 2000 to that in 2002?
Provide a short and direct response. 1.07. What is the ratio of the % of GDP of Belarus in 2000 to that in 2002?
Provide a succinct answer. 1.15. What is the ratio of the % of GDP in Lithuania in 2000 to that in 2002?
Your response must be concise. 0.91. What is the ratio of the % of GDP in Venezuela in 2000 to that in 2002?
Your answer should be compact. 1.14. What is the ratio of the % of GDP in European Union in 2001 to that in 2002?
Ensure brevity in your answer.  1.04. What is the ratio of the % of GDP in Belarus in 2001 to that in 2002?
Keep it short and to the point. 1.07. What is the ratio of the % of GDP in Lithuania in 2001 to that in 2002?
Offer a very short reply. 0.92. What is the ratio of the % of GDP of Venezuela in 2001 to that in 2002?
Provide a short and direct response. 1.3. What is the difference between the highest and the second highest % of GDP in European Union?
Ensure brevity in your answer.  0.61. What is the difference between the highest and the second highest % of GDP of Belarus?
Make the answer very short. 0.12. What is the difference between the highest and the second highest % of GDP of Lithuania?
Give a very brief answer. 0.19. What is the difference between the highest and the second highest % of GDP of Venezuela?
Provide a succinct answer. 2.99. What is the difference between the highest and the lowest % of GDP of European Union?
Make the answer very short. 1.6. What is the difference between the highest and the lowest % of GDP in Belarus?
Keep it short and to the point. 4.66. What is the difference between the highest and the lowest % of GDP of Lithuania?
Your answer should be compact. 5.75. What is the difference between the highest and the lowest % of GDP of Venezuela?
Keep it short and to the point. 14.11. 